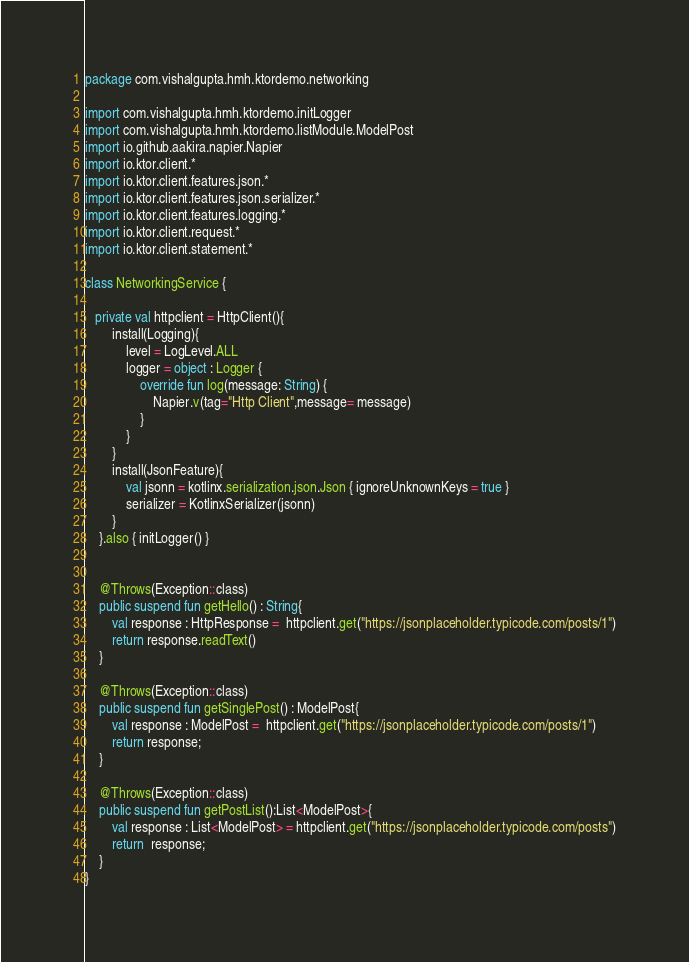Convert code to text. <code><loc_0><loc_0><loc_500><loc_500><_Kotlin_>package com.vishalgupta.hmh.ktordemo.networking

import com.vishalgupta.hmh.ktordemo.initLogger
import com.vishalgupta.hmh.ktordemo.listModule.ModelPost
import io.github.aakira.napier.Napier
import io.ktor.client.*
import io.ktor.client.features.json.*
import io.ktor.client.features.json.serializer.*
import io.ktor.client.features.logging.*
import io.ktor.client.request.*
import io.ktor.client.statement.*

class NetworkingService {

   private val httpclient = HttpClient(){
        install(Logging){
            level = LogLevel.ALL
            logger = object : Logger {
                override fun log(message: String) {
                    Napier.v(tag="Http Client",message= message)
                }
            }
        }
        install(JsonFeature){
            val jsonn = kotlinx.serialization.json.Json { ignoreUnknownKeys = true }
            serializer = KotlinxSerializer(jsonn)
        }
    }.also { initLogger() }


    @Throws(Exception::class)
    public suspend fun getHello() : String{
        val response : HttpResponse =  httpclient.get("https://jsonplaceholder.typicode.com/posts/1")
        return response.readText()
    }

    @Throws(Exception::class)
    public suspend fun getSinglePost() : ModelPost{
        val response : ModelPost =  httpclient.get("https://jsonplaceholder.typicode.com/posts/1")
        return response;
    }

    @Throws(Exception::class)
    public suspend fun getPostList():List<ModelPost>{
        val response : List<ModelPost> = httpclient.get("https://jsonplaceholder.typicode.com/posts")
        return  response;
    }
}</code> 